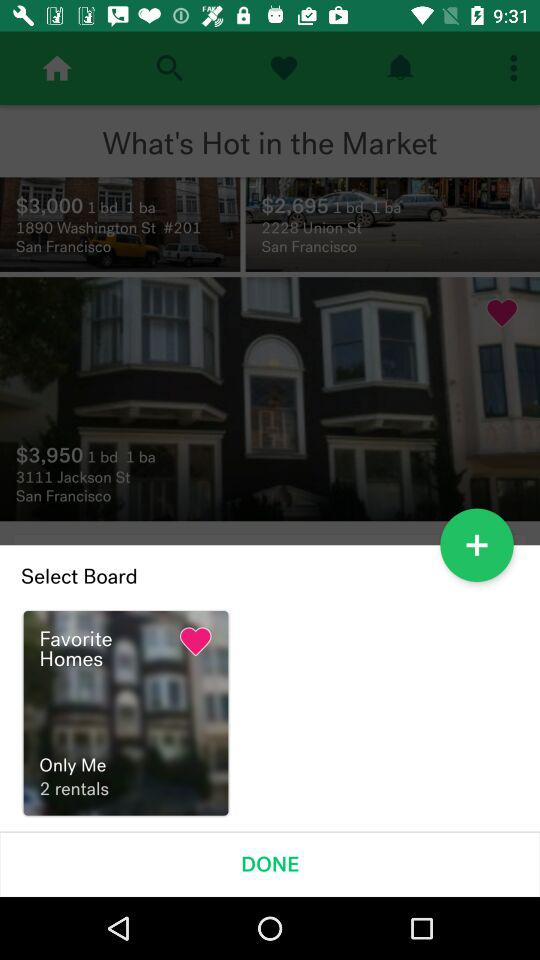How many rentals are in my favorites?
Answer the question using a single word or phrase. 2 